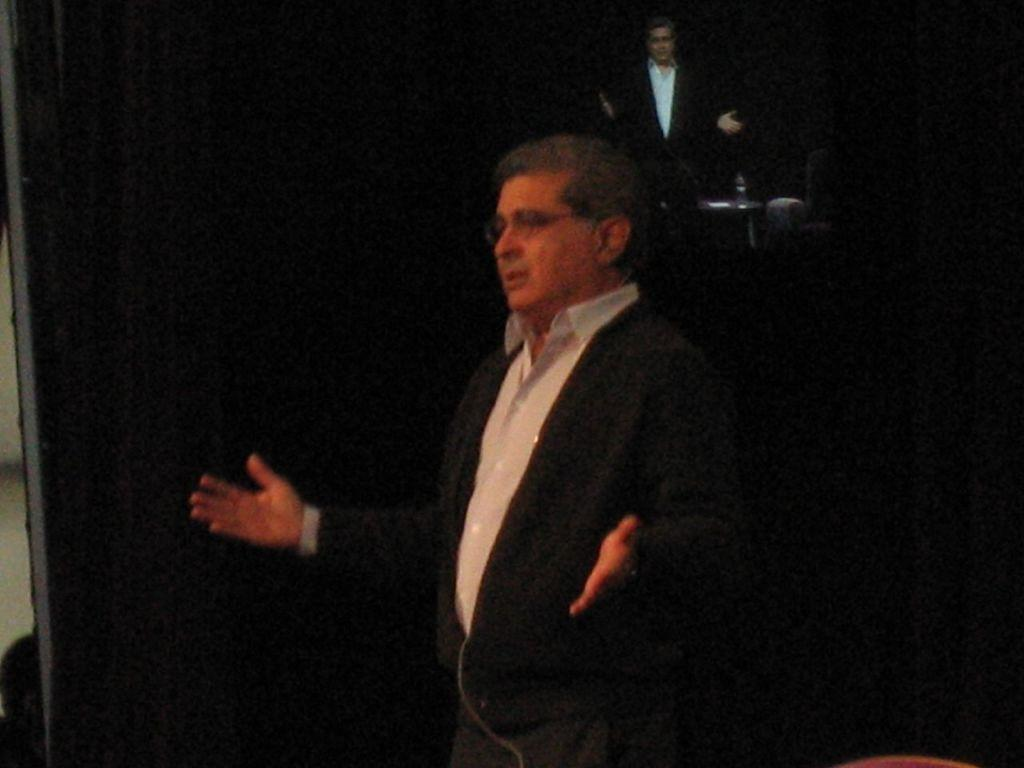What is the main subject in the image? There is a person standing in the image. What can be seen behind the person in the image? The background of the image is black. What type of juice is being poured from the cloud in the image? There is no cloud or juice present in the image. 